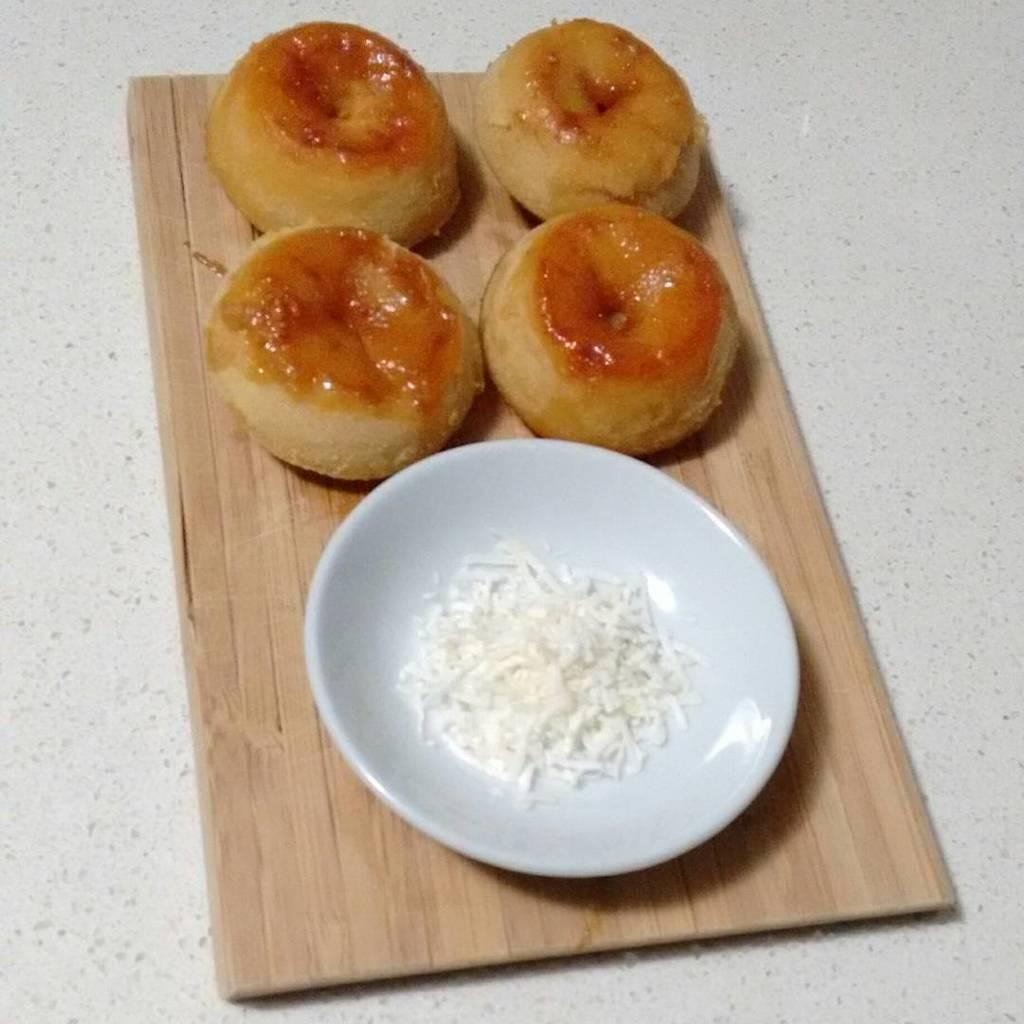What is the color of the plate in the image? The plate in the image is white. What is on the plate? There are food items on the plate. What is the plate resting on? The plate is on a wooden object. What type of arm is visible in the image? There is no arm present in the image. What kind of cart is used to transport the plate in the image? There is no cart present in the image; the plate is resting on a wooden object. 